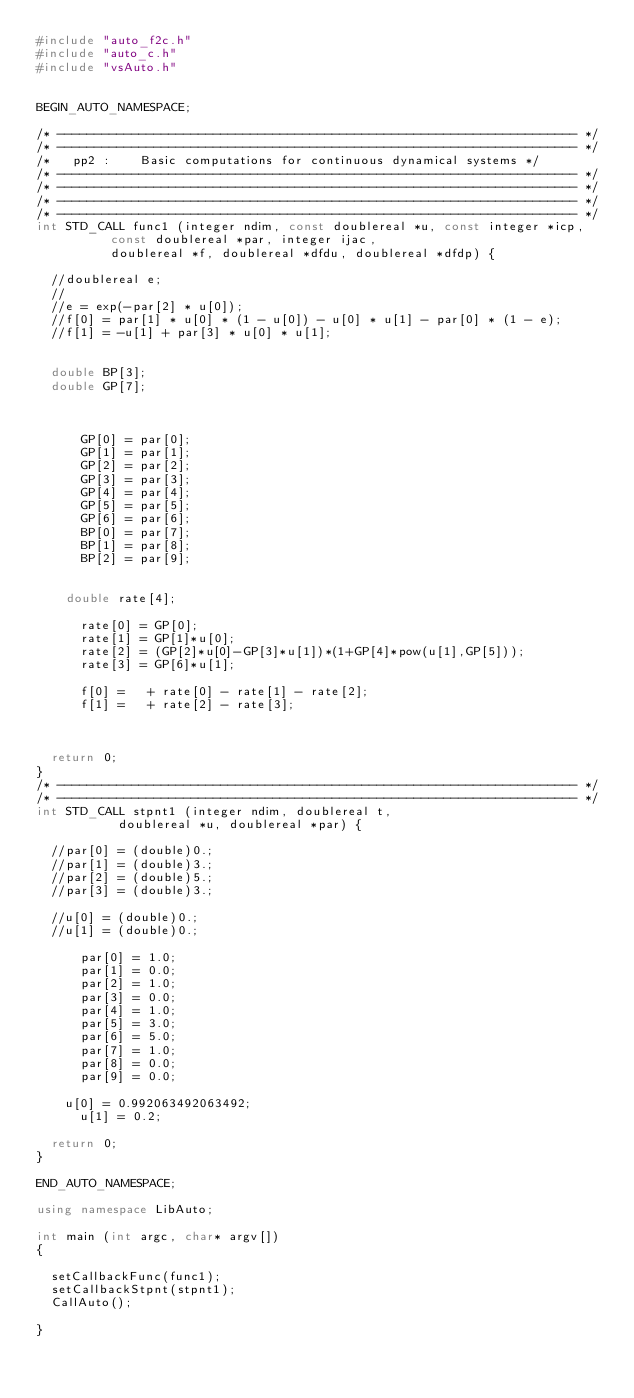<code> <loc_0><loc_0><loc_500><loc_500><_C++_>#include "auto_f2c.h"
#include "auto_c.h"
#include "vsAuto.h"


BEGIN_AUTO_NAMESPACE;

/* ---------------------------------------------------------------------- */
/* ---------------------------------------------------------------------- */
/*   pp2 :    Basic computations for continuous dynamical systems */
/* ---------------------------------------------------------------------- */
/* ---------------------------------------------------------------------- */
/* ---------------------------------------------------------------------- */
/* ---------------------------------------------------------------------- */
int STD_CALL func1 (integer ndim, const doublereal *u, const integer *icp,
          const doublereal *par, integer ijac,
          doublereal *f, doublereal *dfdu, doublereal *dfdp) {

  //doublereal e;
  //
  //e = exp(-par[2] * u[0]);
  //f[0] = par[1] * u[0] * (1 - u[0]) - u[0] * u[1] - par[0] * (1 - e);
  //f[1] = -u[1] + par[3] * u[0] * u[1];
  

	double BP[3];
	double GP[7];

      

      GP[0] = par[0];
      GP[1] = par[1];
      GP[2] = par[2];
      GP[3] = par[3];
      GP[4] = par[4];
      GP[5] = par[5];
      GP[6] = par[6];
      BP[0] = par[7];
      BP[1] = par[8];
      BP[2] = par[9];


	  double rate[4];

      rate[0] = GP[0];
      rate[1] = GP[1]*u[0];
      rate[2] = (GP[2]*u[0]-GP[3]*u[1])*(1+GP[4]*pow(u[1],GP[5]));
      rate[3] = GP[6]*u[1];

      f[0] =   + rate[0] - rate[1] - rate[2];
      f[1] =   + rate[2] - rate[3];
        


  return 0;
} 
/* ---------------------------------------------------------------------- */
/* ---------------------------------------------------------------------- */
int STD_CALL stpnt1 (integer ndim, doublereal t,
           doublereal *u, doublereal *par) {

  //par[0] = (double)0.;
  //par[1] = (double)3.;
  //par[2] = (double)5.;
  //par[3] = (double)3.;

  //u[0] = (double)0.;
  //u[1] = (double)0.;

      par[0] = 1.0;
      par[1] = 0.0;
      par[2] = 1.0;
      par[3] = 0.0;
      par[4] = 1.0;
      par[5] = 3.0;
      par[6] = 5.0;
      par[7] = 1.0;
      par[8] = 0.0;
      par[9] = 0.0;

	  u[0] = 0.992063492063492;
      u[1] = 0.2;

  return 0;
}

END_AUTO_NAMESPACE;

using namespace LibAuto;

int main (int argc, char* argv[])
{

	setCallbackFunc(func1);
	setCallbackStpnt(stpnt1);
	CallAuto();

}</code> 